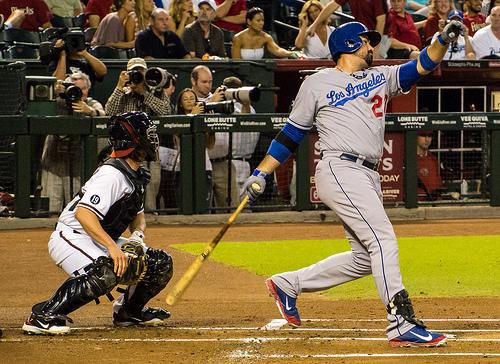Analyze the interaction between the baseball batter and the catcher. The baseball batter has just swung at a pitch while the catcher, squatting down, is looking at the ball. How many people are watching the baseball game? There are 9 people watching the baseball game. Give a short description of the baseball player holding the bat. The batter is a bearded man wearing a shiny blue helmet, grey shirt with red numbers, and blue and red Nike shoes. Identify the type of field the game is being played on and the condition of the field. The game is being played on a baseball field with a brown dirt patch, green grass, white lines on the sand, and a green fence. Provide a description of the catcher in the image. The catcher is wearing a gray baseball shirt with blue letters, gray baseball pants with a blue stripe on the side, black and gray shin and knee pads, and a catcher's helmet. What is the main activity happening in the image? A baseball game being played with people in the background watching. Describe the scene in terms of the setting and time of day. It is a scene outside during the daytime at a baseball field. What is the sentiment in the image? The sentiment in the image is excitement and anticipation due to the ongoing baseball game. Which brand of shoes is the batter wearing and what is the color and design of the shoes? The batter is wearing Nike shoes that are blue and red with a white emblem. Discuss the role of people with cameras in the image. Several people with cameras are taking pictures of the ongoing baseball game, capturing the action and memorable moments. What activity is taking place in the image? Baseball game What are the people with cameras doing? Taking pictures Which statement is true? a) The batter is wearing a red helmet; b) The batter is holding a wooden baseball bat; c) The batter is wearing black shoes. b) The batter is holding a wooden baseball bat What is the task of the man in a catchers mask? Catching the ball as a catcher What color is the shoe with the Nike logo on it? Blue How many people are observing the baseball game? 9 people Provide a short description of the scene. A baseball game being played during the day time with many people watching and taking pictures. What is the role of the person squatting down in the image? Baseball player catcher Which object is being used by the baseball player who just swung at a pitch? Wooden baseball bat What kind of shoes is the man playing baseball wearing? Blue and red Nike shoes Which player is wearing a blue helmet? Man playing baseball Which statement is true? a) A man is playing football; b) A baseball game is happening; c) A soccer match is happening. b) A baseball game is happening What are the people in the background doing? Watching the baseball game Identify the object being worn by the catcher. Catchers helmet, black and gray shin and knee pads Describe the outfit of the person holding a wooden baseball bat. Gray baseball shirt with blue letters, gray shirt with red numbers, gray baseball pants with blue stripe on side, blue and red shoes with white emblem 